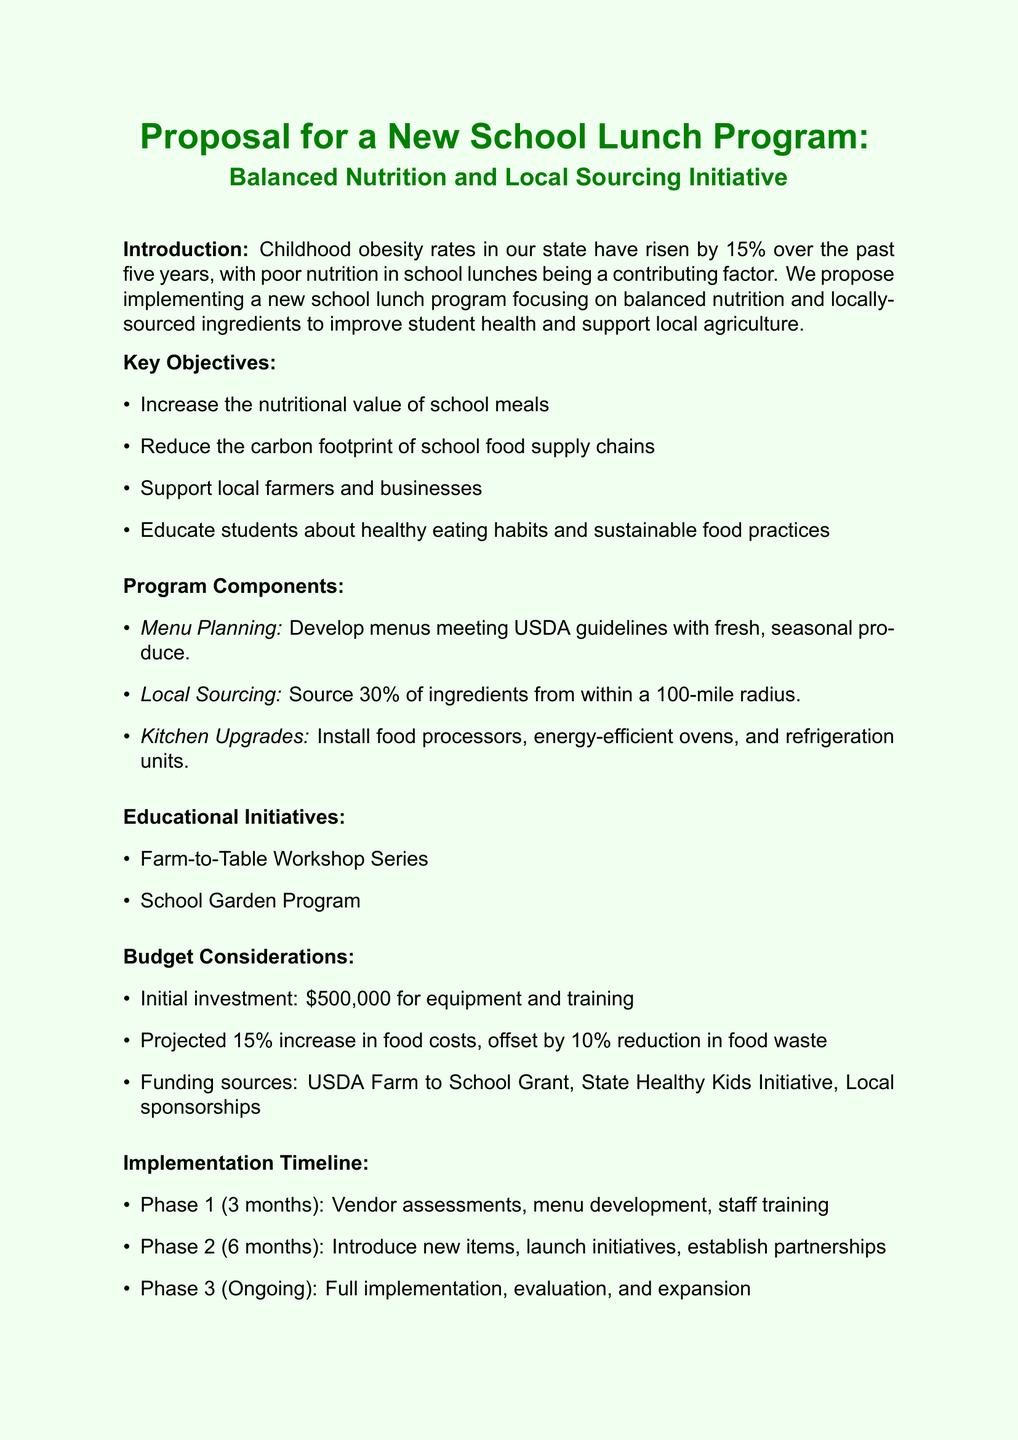What is the percentage increase in childhood obesity rates over the past five years? The memo states that childhood obesity rates have risen by 15% over the past five years.
Answer: 15% What is the target percentage for local sourcing of ingredients within a 100-mile radius? The proposal mentions sourcing at least 30% of ingredients from within a 100-mile radius.
Answer: 30% What is the estimated cost for kitchen equipment upgrades per school? The document specifies an estimated cost of $75,000 per school for kitchen equipment upgrades.
Answer: $75,000 What are the potential funding sources mentioned in the budget considerations? The memo lists several potential funding sources, including USDA Farm to School Grant Program and State Healthy Kids Initiative.
Answer: USDA Farm to School Grant Program, State Healthy Kids Initiative How long is Phase 1 of the implementation timeline? Phase 1 of the implementation timeline is detailed as lasting 3 months.
Answer: 3 months What is one expected outcome of the proposed lunch program? The document outlines multiple expected outcomes, including a 5% reduction in childhood obesity rates within two years.
Answer: 5% reduction in childhood obesity rates What initiative educates students about food production and preparation? The Farm-to-Table Workshop Series is mentioned as a monthly workshop that educates students about food production and preparation.
Answer: Farm-to-Table Workshop Series What is the initial investment budgeted for the program? The proposal states that the initial investment needed is $500,000 for equipment and training.
Answer: $500,000 